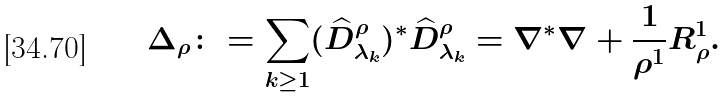<formula> <loc_0><loc_0><loc_500><loc_500>\Delta _ { \rho } \colon = \sum _ { k \geq 1 } ( \widehat { D } ^ { \rho } _ { \lambda _ { k } } ) ^ { \ast } \widehat { D } ^ { \rho } _ { \lambda _ { k } } = \nabla ^ { \ast } \nabla + \frac { 1 } { \rho ^ { 1 } } R _ { \rho } ^ { 1 } .</formula> 